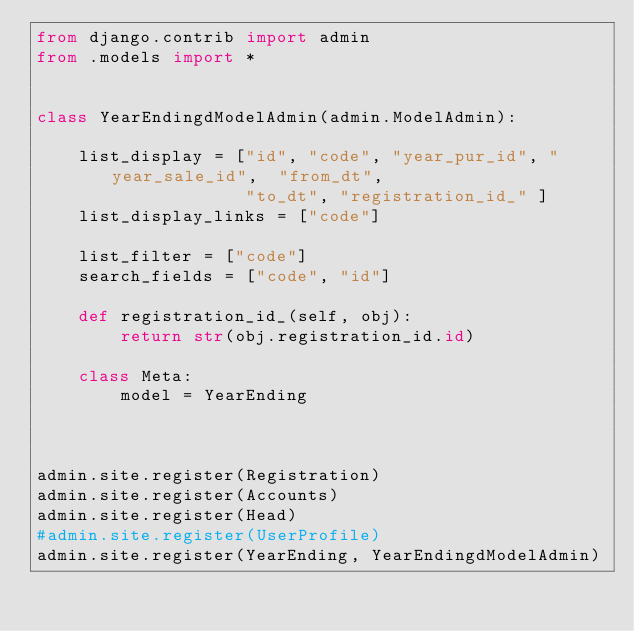<code> <loc_0><loc_0><loc_500><loc_500><_Python_>from django.contrib import admin
from .models import *


class YearEndingdModelAdmin(admin.ModelAdmin):

	list_display = ["id", "code", "year_pur_id", "year_sale_id",  "from_dt", 
					"to_dt", "registration_id_" ]
	list_display_links = ["code"]

	list_filter = ["code"]
	search_fields = ["code", "id"]

	def registration_id_(self, obj):
	    return str(obj.registration_id.id)

	class Meta:
	    model = YearEnding



admin.site.register(Registration)
admin.site.register(Accounts)
admin.site.register(Head)
#admin.site.register(UserProfile)
admin.site.register(YearEnding, YearEndingdModelAdmin)</code> 